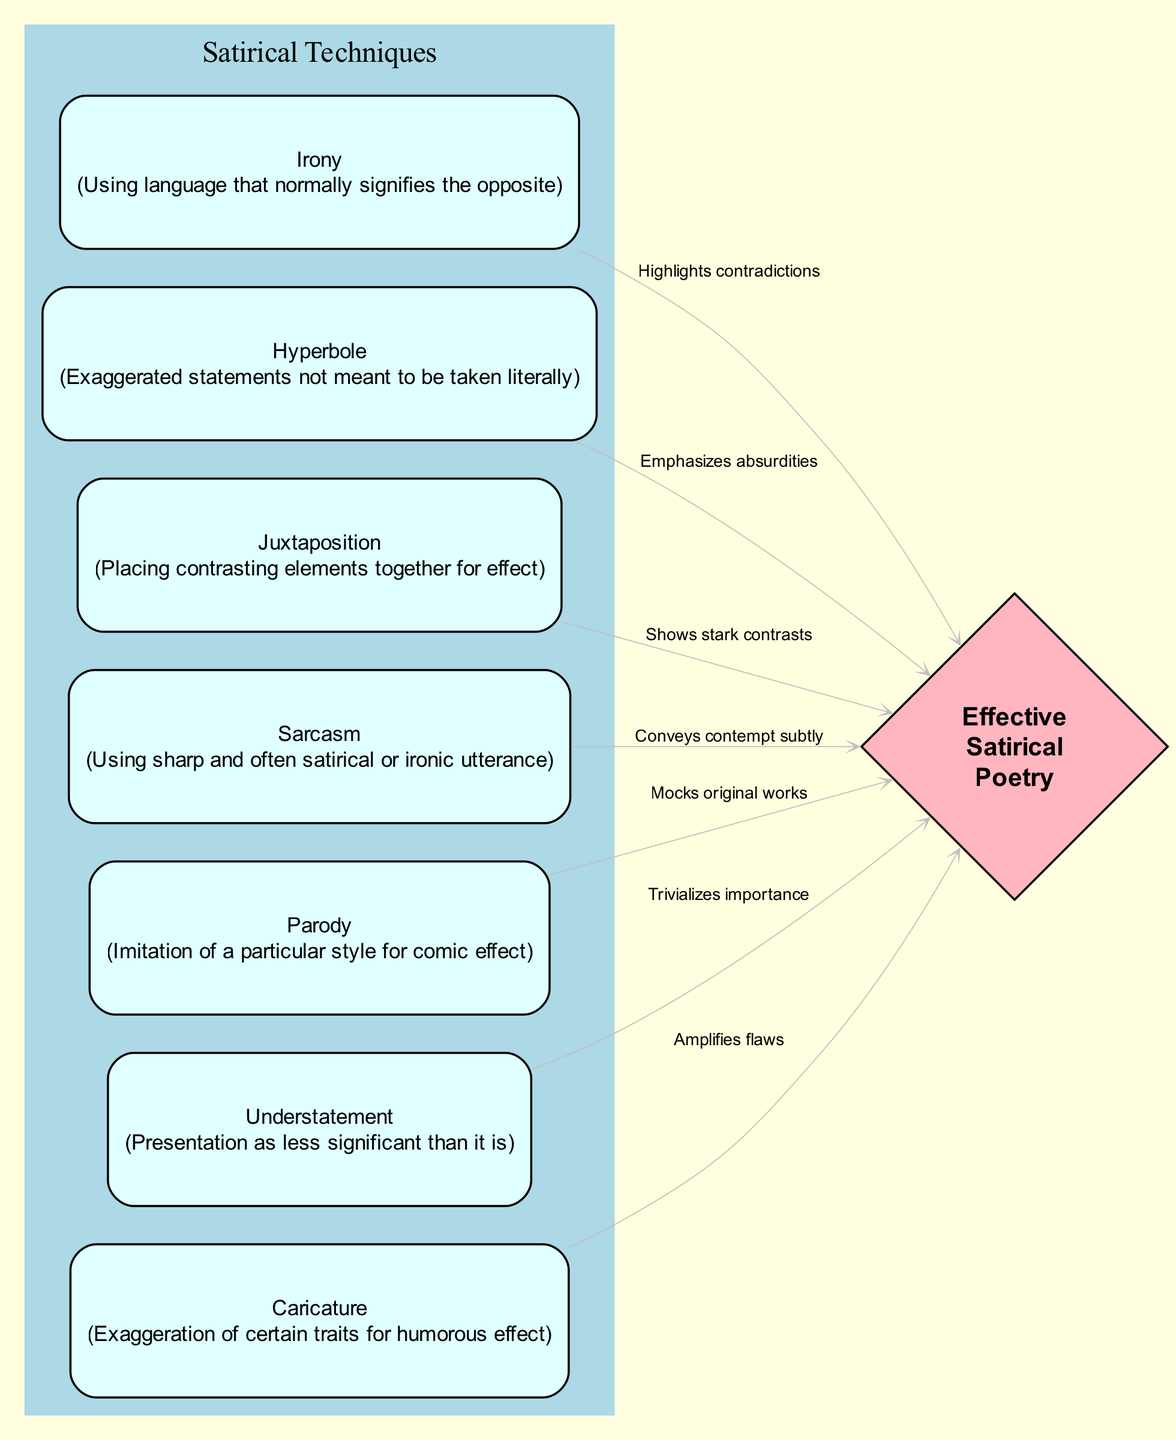What are the four main techniques listed in this diagram? The diagram specifies seven techniques: Irony, Hyperbole, Juxtaposition, Sarcasm, Parody, Understatement, and Caricature. Thus, choosing the first four gives us Irony, Hyperbole, Juxtaposition, and Sarcasm.
Answer: Irony, Hyperbole, Juxtaposition, Sarcasm How many edges are present in the diagram? The edges are used to show the connections between techniques and the goal of effective satire. There are seven edges shown in the diagram.
Answer: 7 Which technique emphasizes absurdities? By looking at the diagram, Hyperbole is indicated as the technique that emphasizes absurdities, as denoted by the edge labeled "Emphasizes absurdities."
Answer: Hyperbole What does Juxtaposition show in relation to satire? In the diagram, Juxtaposition is linked to the goal of effective satire with the label "Shows stark contrasts," indicating its role in highlighting differences.
Answer: Shows stark contrasts Which technique conveys contempt subtly? The diagram indicates that Sarcasm is the technique described as conveying contempt subtly, as evidenced by the label on the corresponding edge.
Answer: Sarcasm What is the purpose of using Caricature in satirical poetry? The diagram states that Caricature amplifies flaws through the edge labeled "Amplifies flaws," demonstrating its purpose in satire.
Answer: Amplifies flaws Which poetic technique involves imitation for comic effect? Parody is the technique defined in the diagram as imitating a particular style for comic effect, directly stated in the description of the corresponding node.
Answer: Parody What is the effect of using Irony in satirical poetry? The diagram highlights that Irony highlights contradictions, connecting it to the overall goal of effective satirical poetry.
Answer: Highlights contradictions 